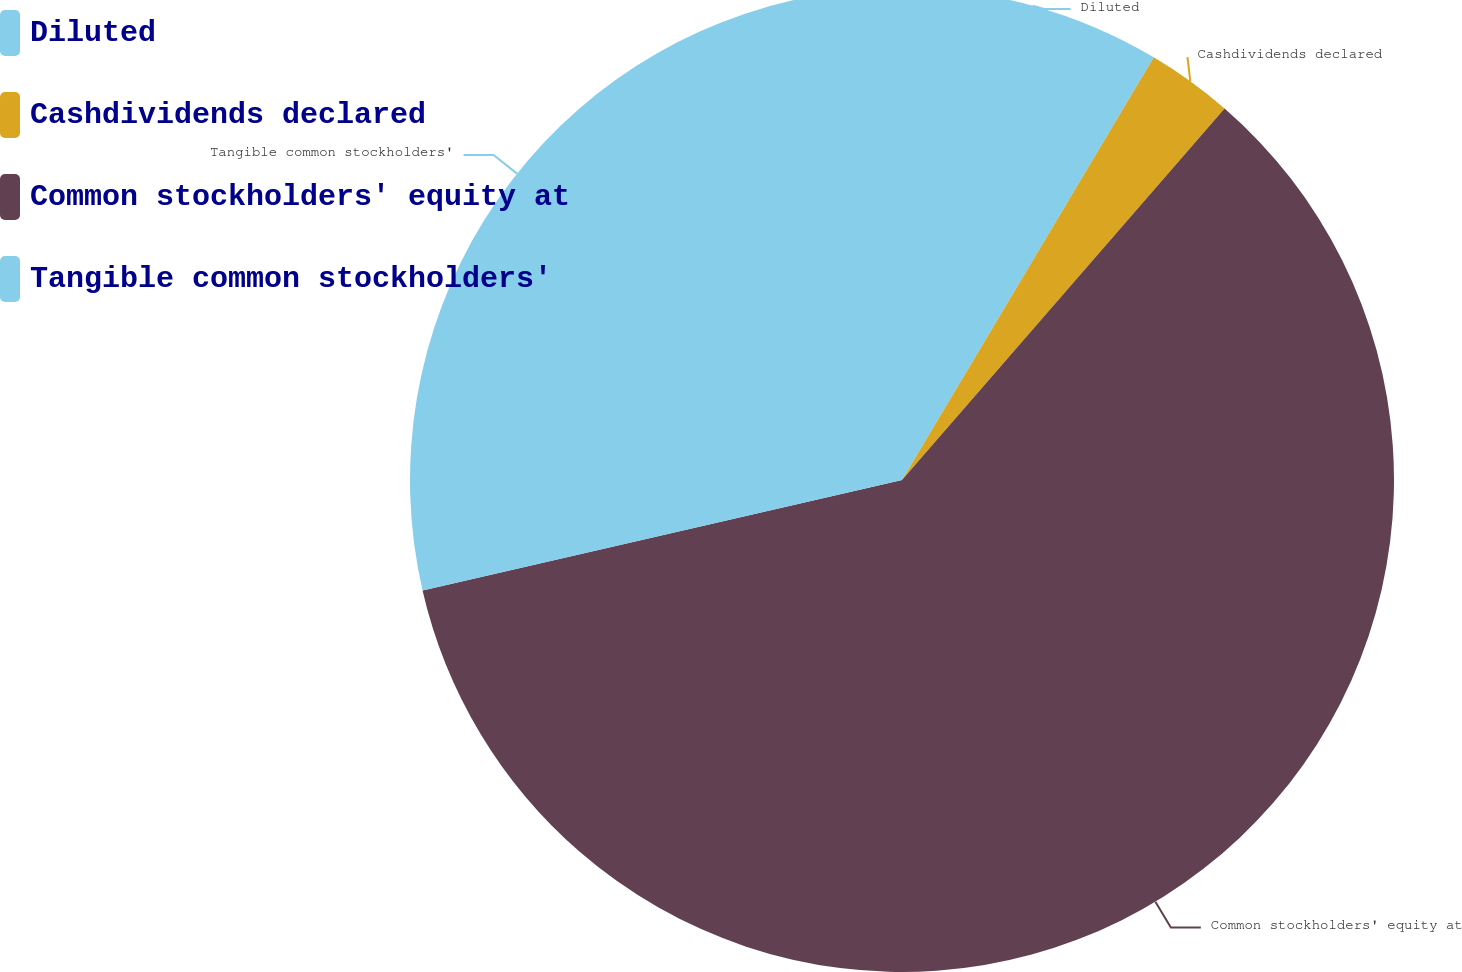Convert chart. <chart><loc_0><loc_0><loc_500><loc_500><pie_chart><fcel>Diluted<fcel>Cashdividends declared<fcel>Common stockholders' equity at<fcel>Tangible common stockholders'<nl><fcel>8.55%<fcel>2.83%<fcel>60.01%<fcel>28.6%<nl></chart> 